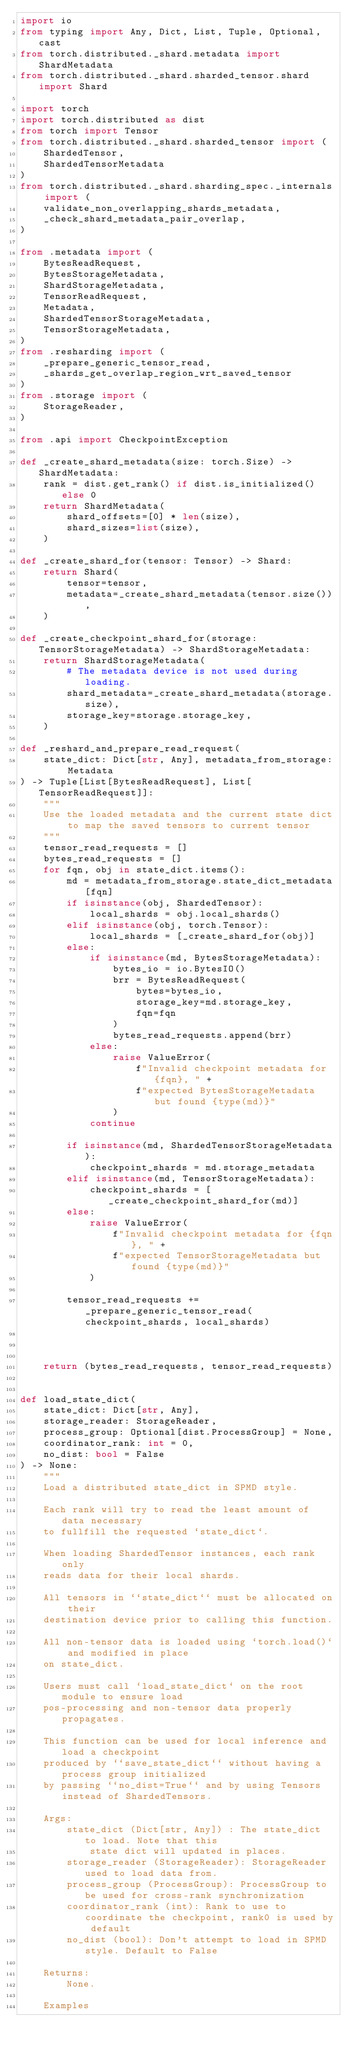<code> <loc_0><loc_0><loc_500><loc_500><_Python_>import io
from typing import Any, Dict, List, Tuple, Optional, cast
from torch.distributed._shard.metadata import ShardMetadata
from torch.distributed._shard.sharded_tensor.shard import Shard

import torch
import torch.distributed as dist
from torch import Tensor
from torch.distributed._shard.sharded_tensor import (
    ShardedTensor,
    ShardedTensorMetadata
)
from torch.distributed._shard.sharding_spec._internals import (
    validate_non_overlapping_shards_metadata,
    _check_shard_metadata_pair_overlap,
)

from .metadata import (
    BytesReadRequest,
    BytesStorageMetadata,
    ShardStorageMetadata,
    TensorReadRequest,
    Metadata,
    ShardedTensorStorageMetadata,
    TensorStorageMetadata,
)
from .resharding import (
    _prepare_generic_tensor_read,
    _shards_get_overlap_region_wrt_saved_tensor
)
from .storage import (
    StorageReader,
)

from .api import CheckpointException

def _create_shard_metadata(size: torch.Size) -> ShardMetadata:
    rank = dist.get_rank() if dist.is_initialized() else 0
    return ShardMetadata(
        shard_offsets=[0] * len(size),
        shard_sizes=list(size),
    )

def _create_shard_for(tensor: Tensor) -> Shard:
    return Shard(
        tensor=tensor,
        metadata=_create_shard_metadata(tensor.size()),
    )

def _create_checkpoint_shard_for(storage: TensorStorageMetadata) -> ShardStorageMetadata:
    return ShardStorageMetadata(
        # The metadata device is not used during loading.
        shard_metadata=_create_shard_metadata(storage.size),
        storage_key=storage.storage_key,
    )

def _reshard_and_prepare_read_request(
    state_dict: Dict[str, Any], metadata_from_storage: Metadata
) -> Tuple[List[BytesReadRequest], List[TensorReadRequest]]:
    """
    Use the loaded metadata and the current state dict to map the saved tensors to current tensor
    """
    tensor_read_requests = []
    bytes_read_requests = []
    for fqn, obj in state_dict.items():
        md = metadata_from_storage.state_dict_metadata[fqn]
        if isinstance(obj, ShardedTensor):
            local_shards = obj.local_shards()
        elif isinstance(obj, torch.Tensor):
            local_shards = [_create_shard_for(obj)]
        else:
            if isinstance(md, BytesStorageMetadata):
                bytes_io = io.BytesIO()
                brr = BytesReadRequest(
                    bytes=bytes_io,
                    storage_key=md.storage_key,
                    fqn=fqn
                )
                bytes_read_requests.append(brr)
            else:
                raise ValueError(
                    f"Invalid checkpoint metadata for {fqn}, " +
                    f"expected BytesStorageMetadata but found {type(md)}"
                )
            continue

        if isinstance(md, ShardedTensorStorageMetadata):
            checkpoint_shards = md.storage_metadata
        elif isinstance(md, TensorStorageMetadata):
            checkpoint_shards = [_create_checkpoint_shard_for(md)]
        else:
            raise ValueError(
                f"Invalid checkpoint metadata for {fqn}, " +
                f"expected TensorStorageMetadata but found {type(md)}"
            )

        tensor_read_requests += _prepare_generic_tensor_read(checkpoint_shards, local_shards)



    return (bytes_read_requests, tensor_read_requests)


def load_state_dict(
    state_dict: Dict[str, Any],
    storage_reader: StorageReader,
    process_group: Optional[dist.ProcessGroup] = None,
    coordinator_rank: int = 0,
    no_dist: bool = False
) -> None:
    """
    Load a distributed state_dict in SPMD style.

    Each rank will try to read the least amount of data necessary
    to fullfill the requested `state_dict`.

    When loading ShardedTensor instances, each rank only
    reads data for their local shards.

    All tensors in ``state_dict`` must be allocated on their
    destination device prior to calling this function.

    All non-tensor data is loaded using `torch.load()` and modified in place
    on state_dict.

    Users must call `load_state_dict` on the root module to ensure load
    pos-processing and non-tensor data properly propagates.

    This function can be used for local inference and load a checkpoint
    produced by ``save_state_dict`` without having a process group initialized
    by passing ``no_dist=True`` and by using Tensors instead of ShardedTensors.

    Args:
        state_dict (Dict[str, Any]) : The state_dict to load. Note that this
            state dict will updated in places.
        storage_reader (StorageReader): StorageReader used to load data from.
        process_group (ProcessGroup): ProcessGroup to be used for cross-rank synchronization
        coordinator_rank (int): Rank to use to coordinate the checkpoint, rank0 is used by default
        no_dist (bool): Don't attempt to load in SPMD style. Default to False

    Returns:
        None.

    Examples</code> 